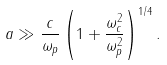<formula> <loc_0><loc_0><loc_500><loc_500>a \gg \frac { c } { \omega _ { p } } \left ( 1 + \frac { \omega _ { c } ^ { 2 } } { \omega _ { p } ^ { 2 } } \right ) ^ { 1 / 4 } .</formula> 